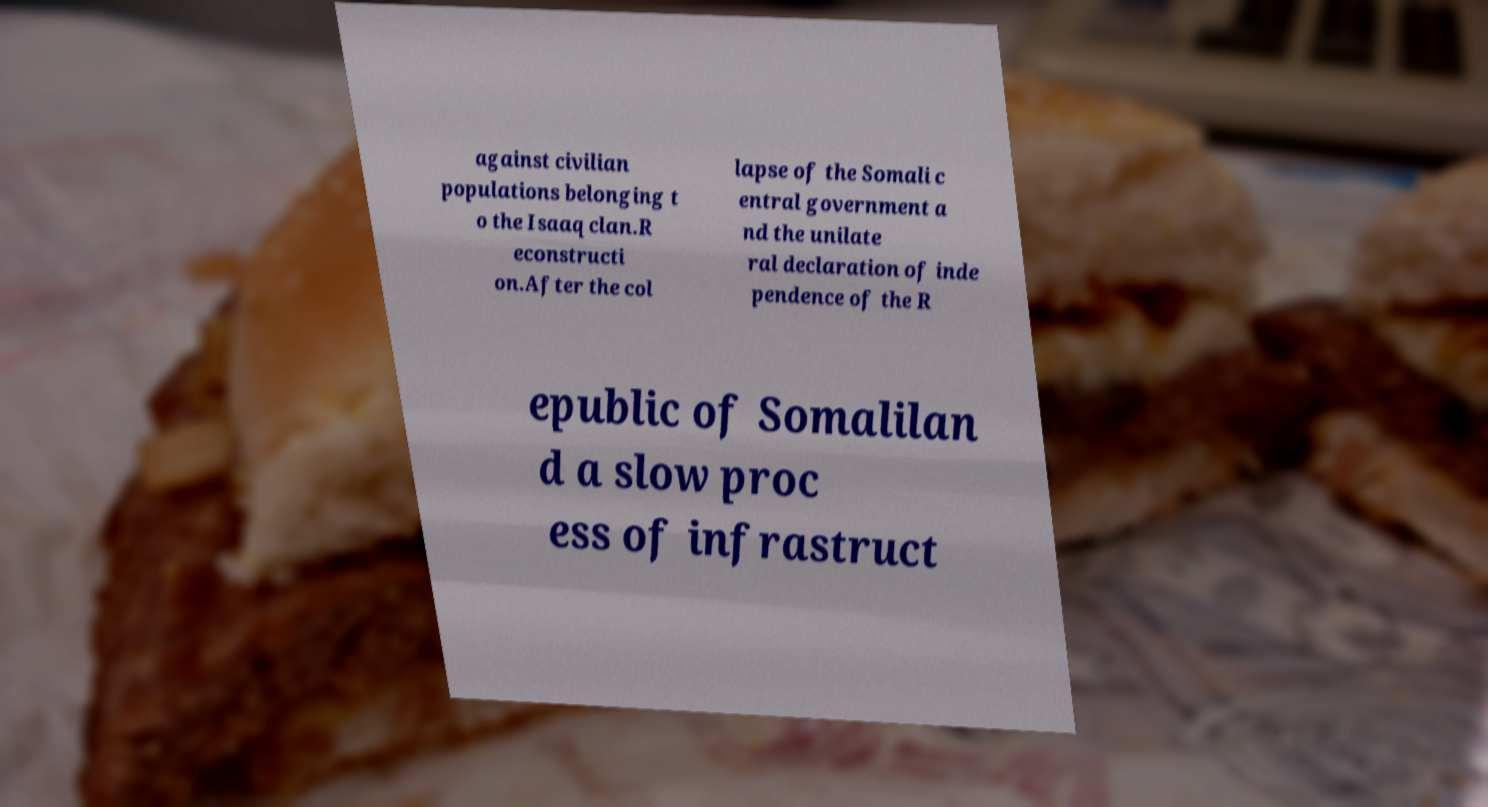Can you accurately transcribe the text from the provided image for me? against civilian populations belonging t o the Isaaq clan.R econstructi on.After the col lapse of the Somali c entral government a nd the unilate ral declaration of inde pendence of the R epublic of Somalilan d a slow proc ess of infrastruct 